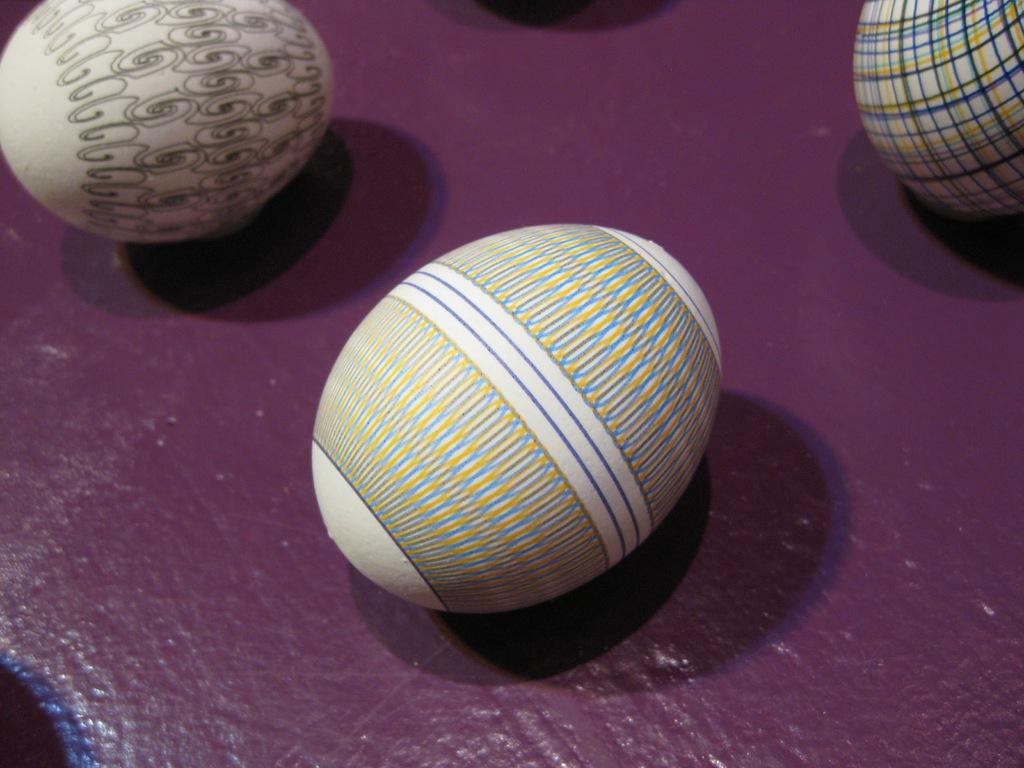What objects are present in the image? There are three eggshells in the image. What is unique about the appearance of the eggshells? The eggshells have designs on them. Where are the eggshells located in the image? The eggshells are placed on a wall. What type of toothbrush is hanging on the wall next to the eggshells? There is no toothbrush present in the image; it only features eggshells with designs on them. 